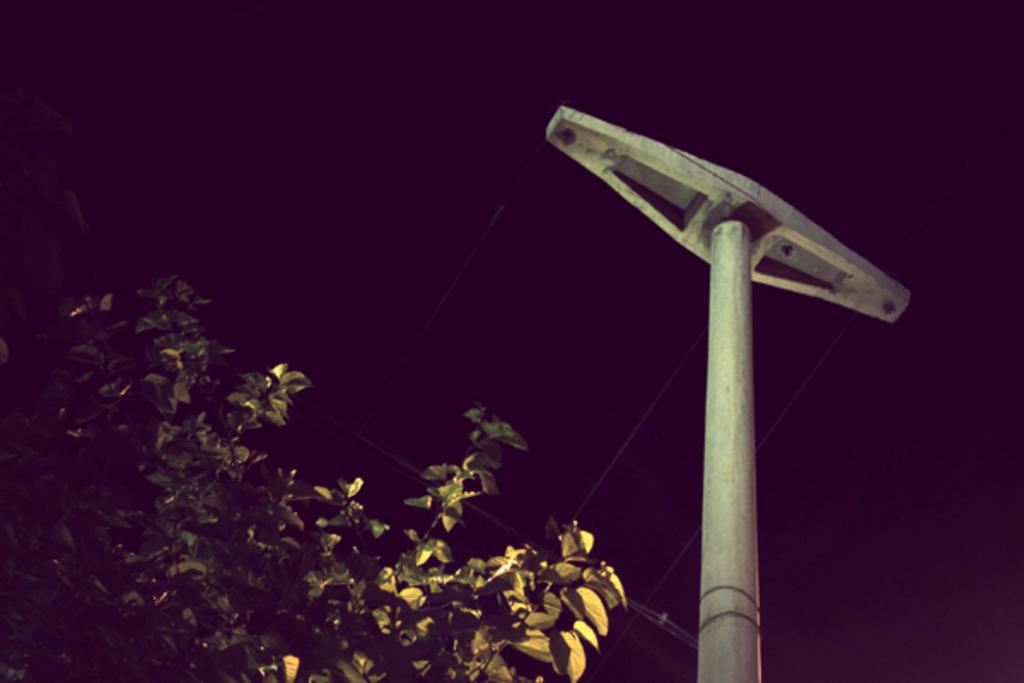What type of plant can be seen in the image? There is a tree in the image. What else is present in the image besides the tree? There is a pole with wires in the image. How would you describe the overall lighting in the image? The background of the image is dark. How much tax is being paid for the tree in the image? There is no tax being paid for the tree in the image, as it is a natural object and not a property or item subject to taxation. 